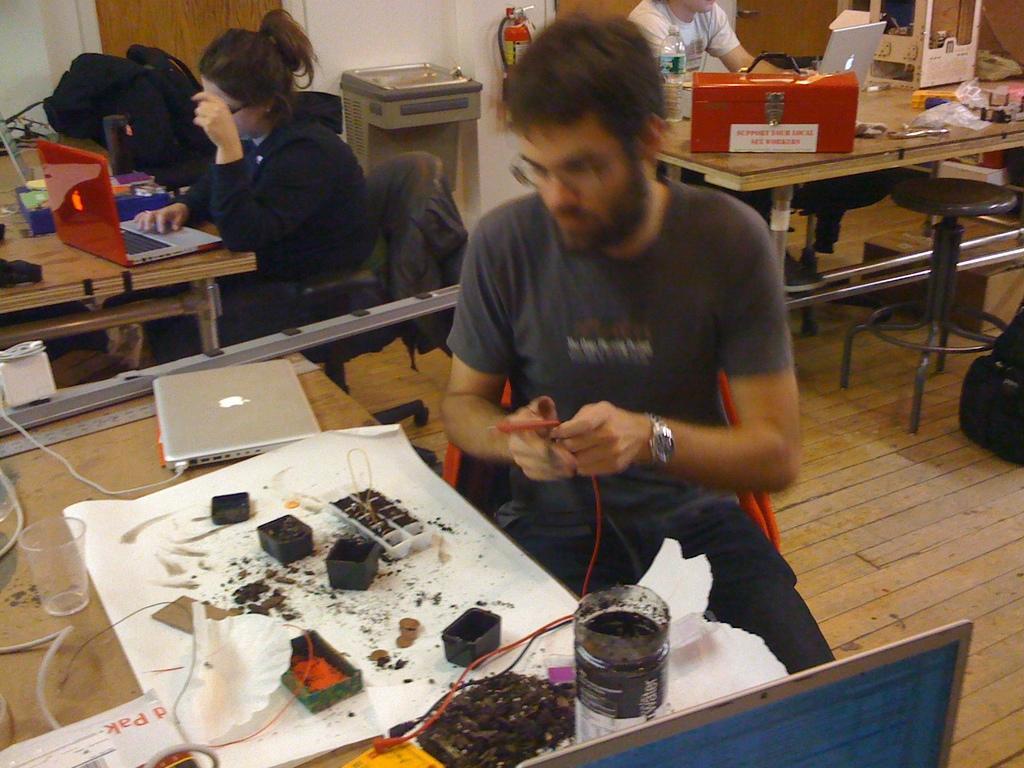Describe this image in one or two sentences. In this picture we can see a one girl and two boys are working in the workshop, a boy wearing grey t- shirt and jean is working on the electronic device and apple laptop on the table, Beside that boy a girl is working on the laptop and there is table on which another person sitting on the table with the tool box is also working on the laptop. behind there is a fire extinguisher can see on the white wall. 